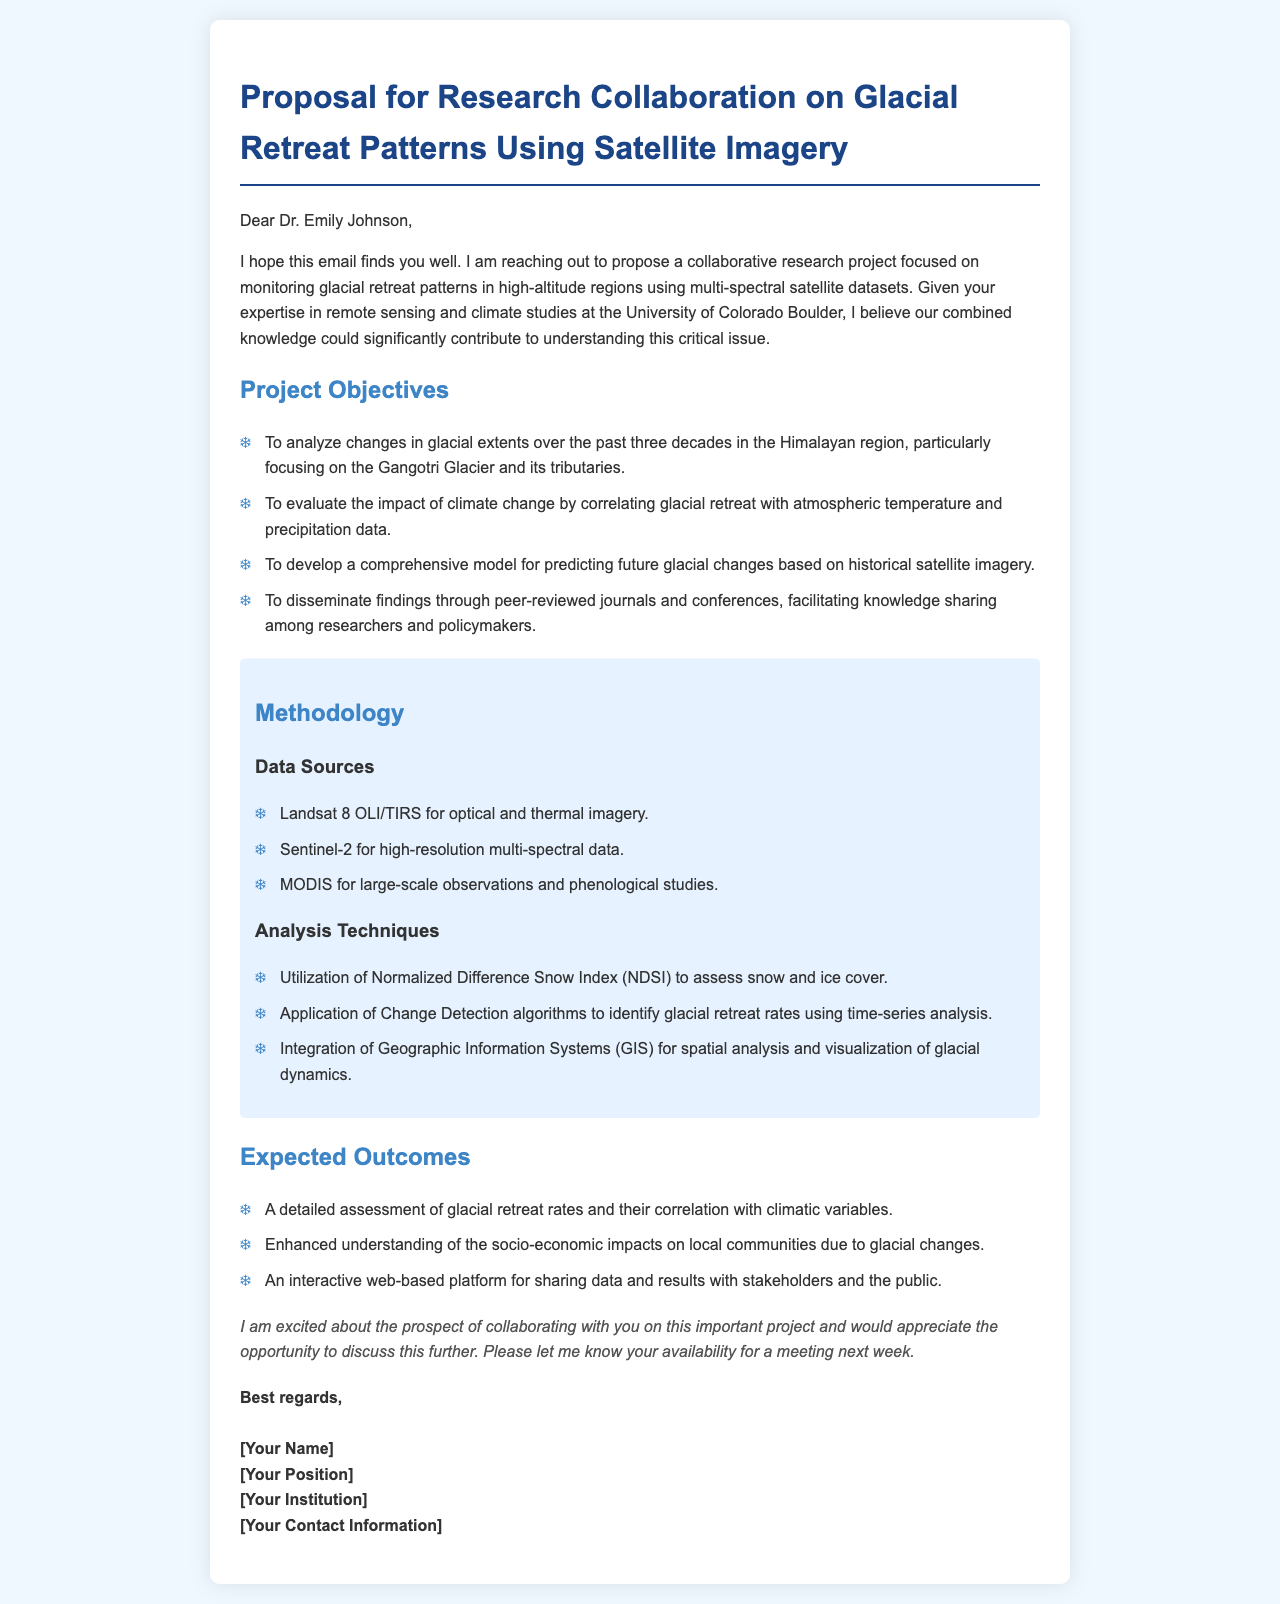What is the title of the proposal? The title summarizes the main topic of the email, which is the focus of the research collaboration.
Answer: Proposal for Research Collaboration on Glacial Retreat Patterns Using Satellite Imagery Who is the intended recipient of the email? The greeting at the beginning of the document indicates who the proposal is addressed to.
Answer: Dr. Emily Johnson What is the main focus area of the research project? The introduction specifies the primary subject of the collaborative research being proposed.
Answer: Monitoring glacial retreat patterns What satellite data source is specifically mentioned for optical imagery? The methodology section lists data sources and specifies which satellite is used for optical imagery.
Answer: Landsat 8 OLI/TIRS How many decades of glacial extent changes are analyzed in the project? The objectives section provides information on the time frame of the study concerning glacial extents.
Answer: Three decades What methodology will be used to assess snow and ice cover? The analysis techniques section outlines the method that will be applied to study snow and ice cover.
Answer: Normalized Difference Snow Index (NDSI) What is one expected outcome of the research? The expected outcomes section describes what the project aims to achieve as a result of the research efforts.
Answer: A detailed assessment of glacial retreat rates What conference or publication strategy is mentioned for disseminating findings? The project objectives indicate how the outcomes of the research will be shared with the wider community.
Answer: Peer-reviewed journals and conferences 